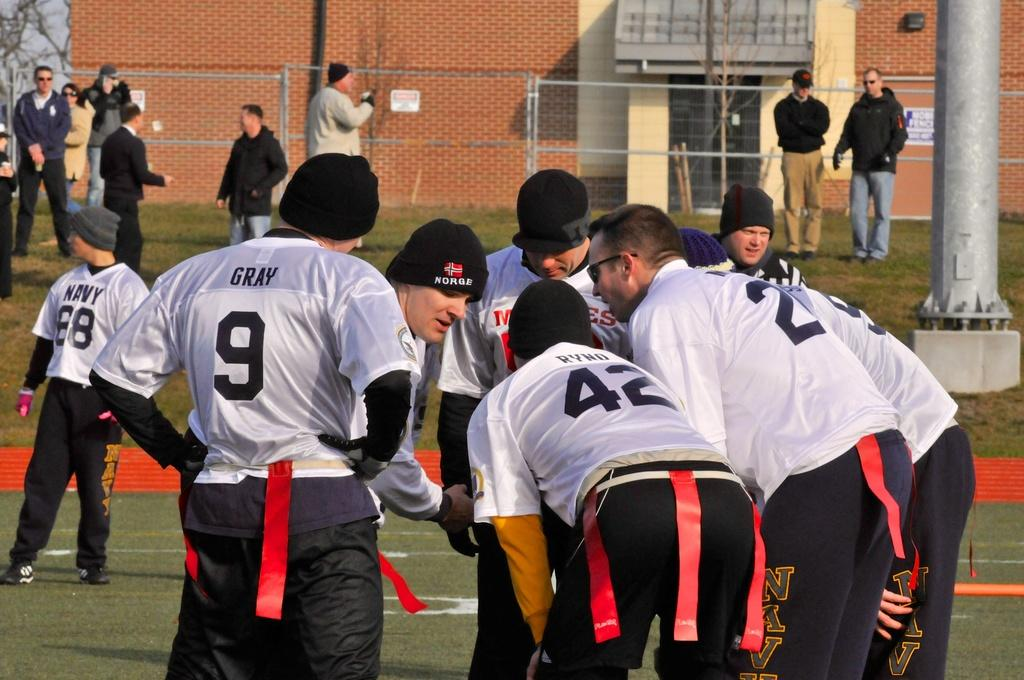Provide a one-sentence caption for the provided image. Team member in a white jersey with Gray on the back in black. 